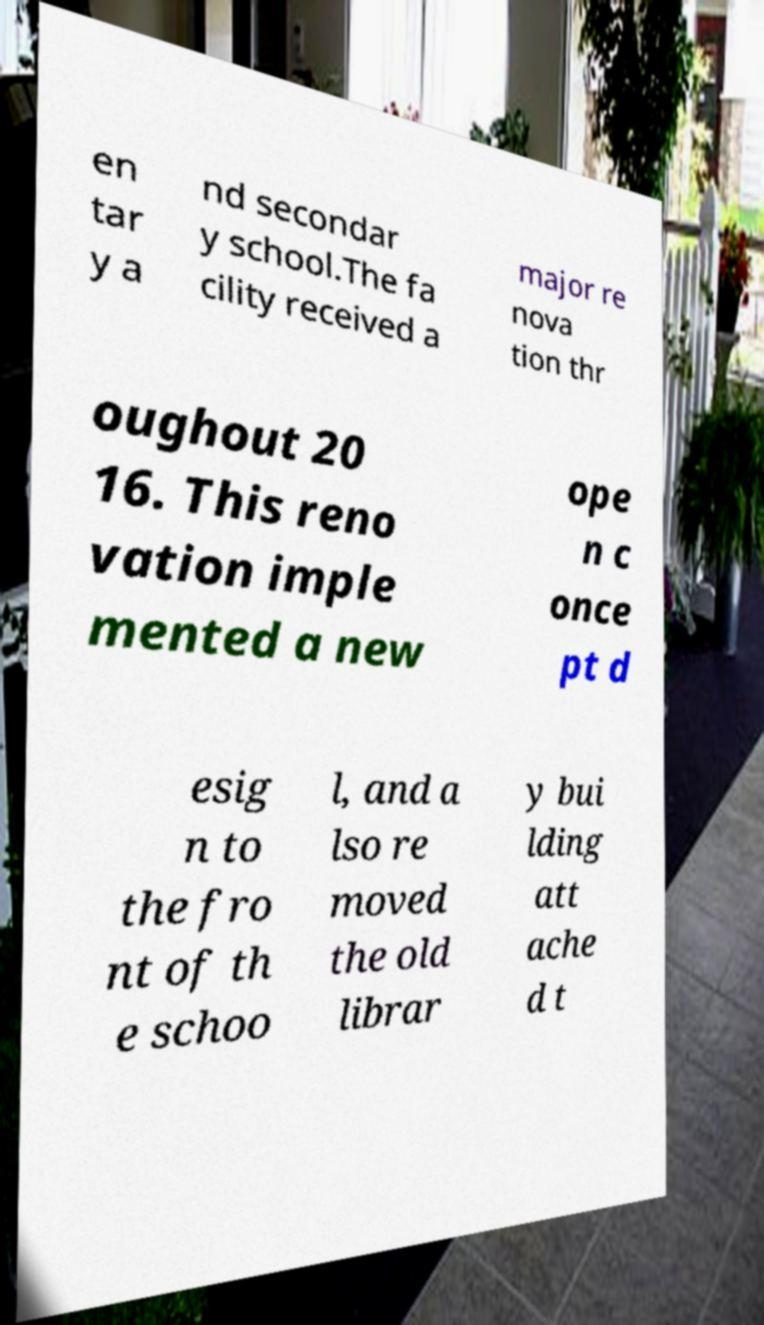For documentation purposes, I need the text within this image transcribed. Could you provide that? en tar y a nd secondar y school.The fa cility received a major re nova tion thr oughout 20 16. This reno vation imple mented a new ope n c once pt d esig n to the fro nt of th e schoo l, and a lso re moved the old librar y bui lding att ache d t 